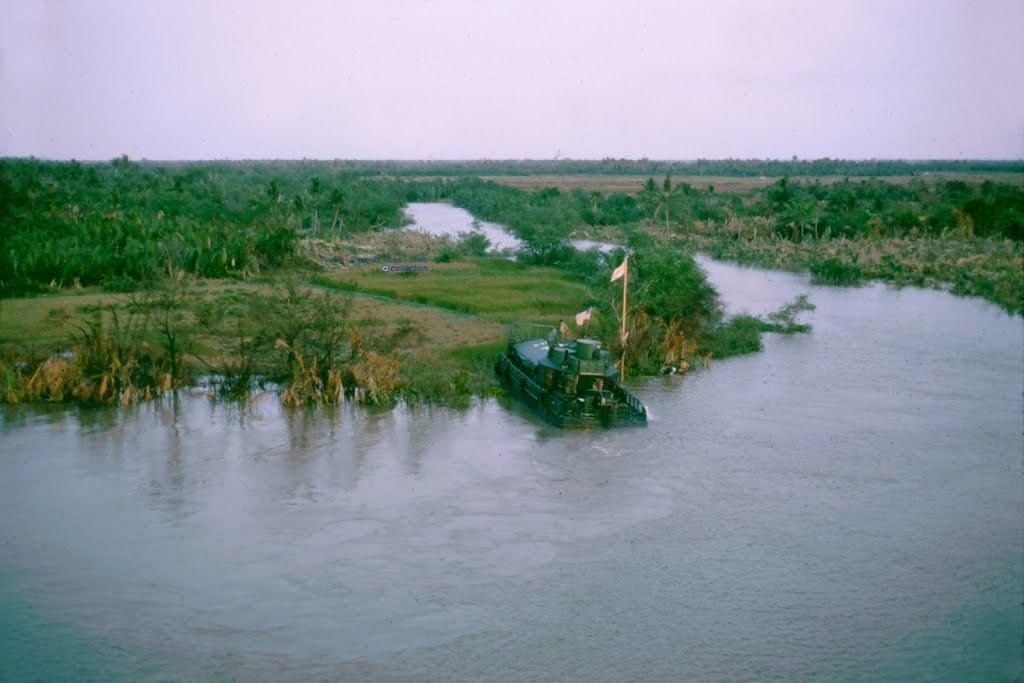Describe this image in one or two sentences. In this image we can see a boat on the surface of the water. We can also see the grass, trees and also the sky at the top. We can also see a flag. 